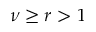<formula> <loc_0><loc_0><loc_500><loc_500>\nu \geq r > 1</formula> 